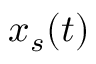<formula> <loc_0><loc_0><loc_500><loc_500>x _ { s } ( t )</formula> 